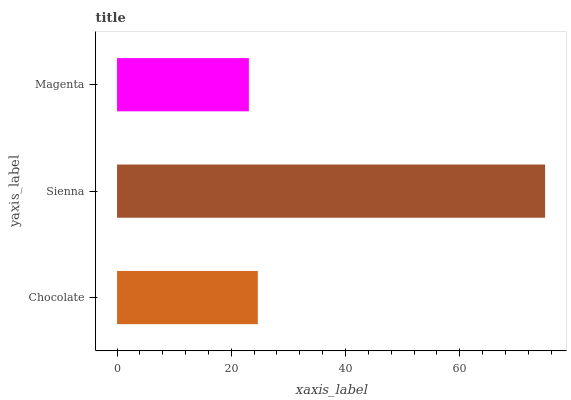Is Magenta the minimum?
Answer yes or no. Yes. Is Sienna the maximum?
Answer yes or no. Yes. Is Sienna the minimum?
Answer yes or no. No. Is Magenta the maximum?
Answer yes or no. No. Is Sienna greater than Magenta?
Answer yes or no. Yes. Is Magenta less than Sienna?
Answer yes or no. Yes. Is Magenta greater than Sienna?
Answer yes or no. No. Is Sienna less than Magenta?
Answer yes or no. No. Is Chocolate the high median?
Answer yes or no. Yes. Is Chocolate the low median?
Answer yes or no. Yes. Is Magenta the high median?
Answer yes or no. No. Is Magenta the low median?
Answer yes or no. No. 